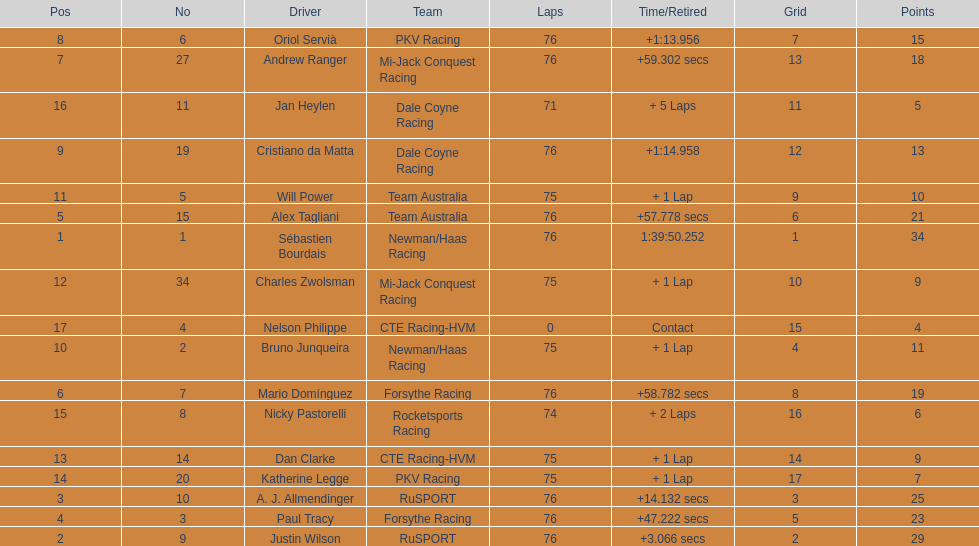Which drivers completed all 76 laps? Sébastien Bourdais, Justin Wilson, A. J. Allmendinger, Paul Tracy, Alex Tagliani, Mario Domínguez, Andrew Ranger, Oriol Servià, Cristiano da Matta. Of these drivers, which ones finished less than a minute behind first place? Paul Tracy, Alex Tagliani, Mario Domínguez, Andrew Ranger. Of these drivers, which ones finished with a time less than 50 seconds behind first place? Justin Wilson, A. J. Allmendinger, Paul Tracy. Of these three drivers, who finished last? Paul Tracy. 